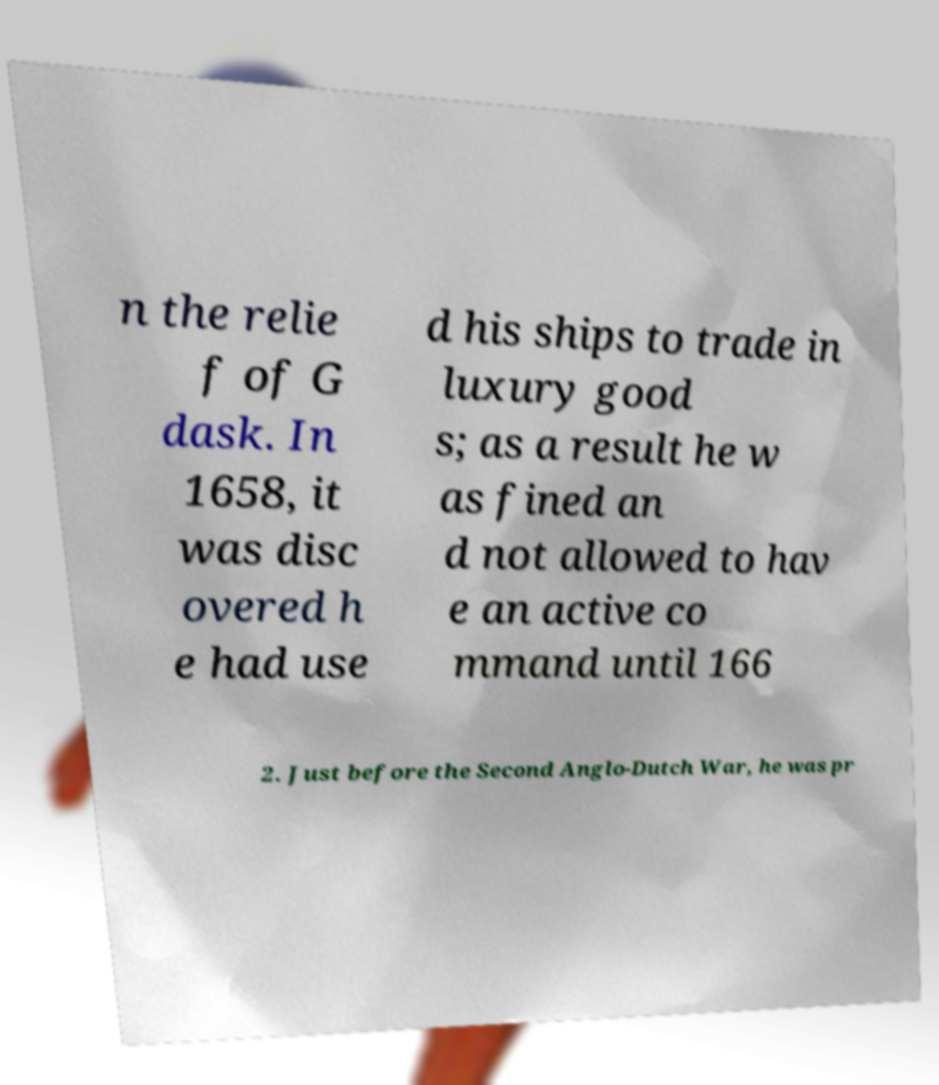Can you accurately transcribe the text from the provided image for me? n the relie f of G dask. In 1658, it was disc overed h e had use d his ships to trade in luxury good s; as a result he w as fined an d not allowed to hav e an active co mmand until 166 2. Just before the Second Anglo-Dutch War, he was pr 